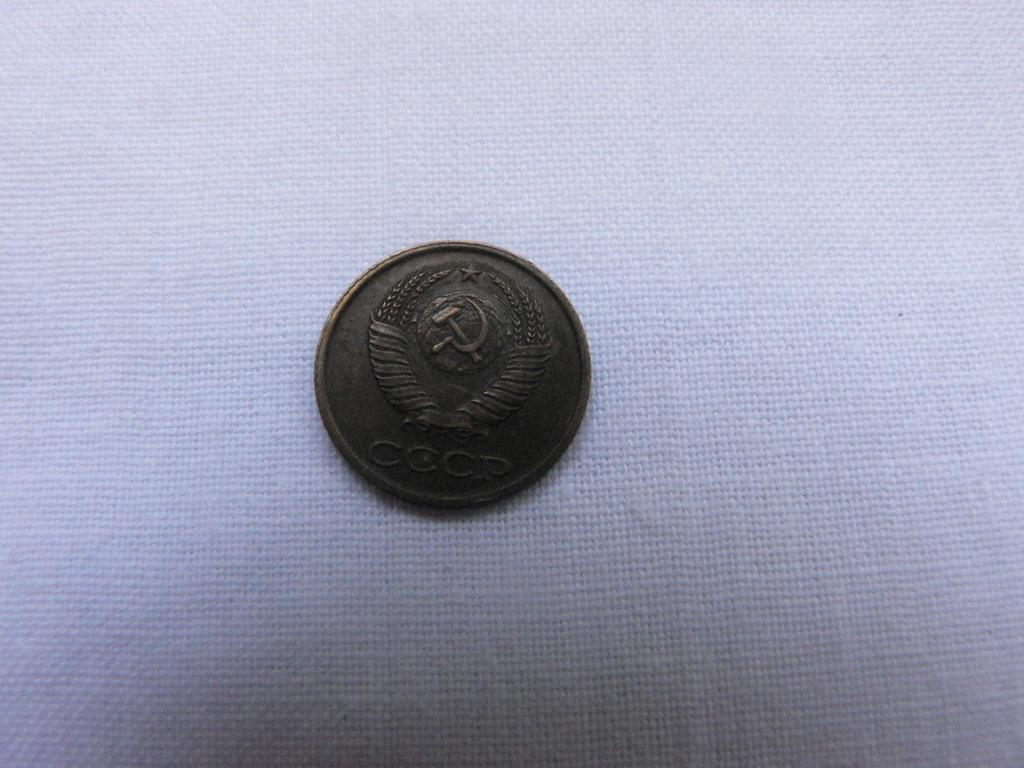What is the main subject of the image? The main subject of the image is an antique coin. What is the value of the finger touching the antique coin in the image? There is no finger touching the antique coin in the image, and therefore no value can be determined. 